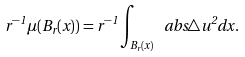Convert formula to latex. <formula><loc_0><loc_0><loc_500><loc_500>r ^ { - 1 } \mu ( B _ { r } ( x ) ) = r ^ { - 1 } \int _ { B _ { r } ( x ) } \ a b s { \triangle u } ^ { 2 } d x .</formula> 